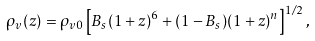Convert formula to latex. <formula><loc_0><loc_0><loc_500><loc_500>\rho _ { v } ( z ) = \rho _ { v 0 } \left [ B _ { s } ( 1 + z ) ^ { 6 } + ( 1 - B _ { s } ) ( 1 + z ) ^ { n } \right ] ^ { 1 / 2 } ,</formula> 